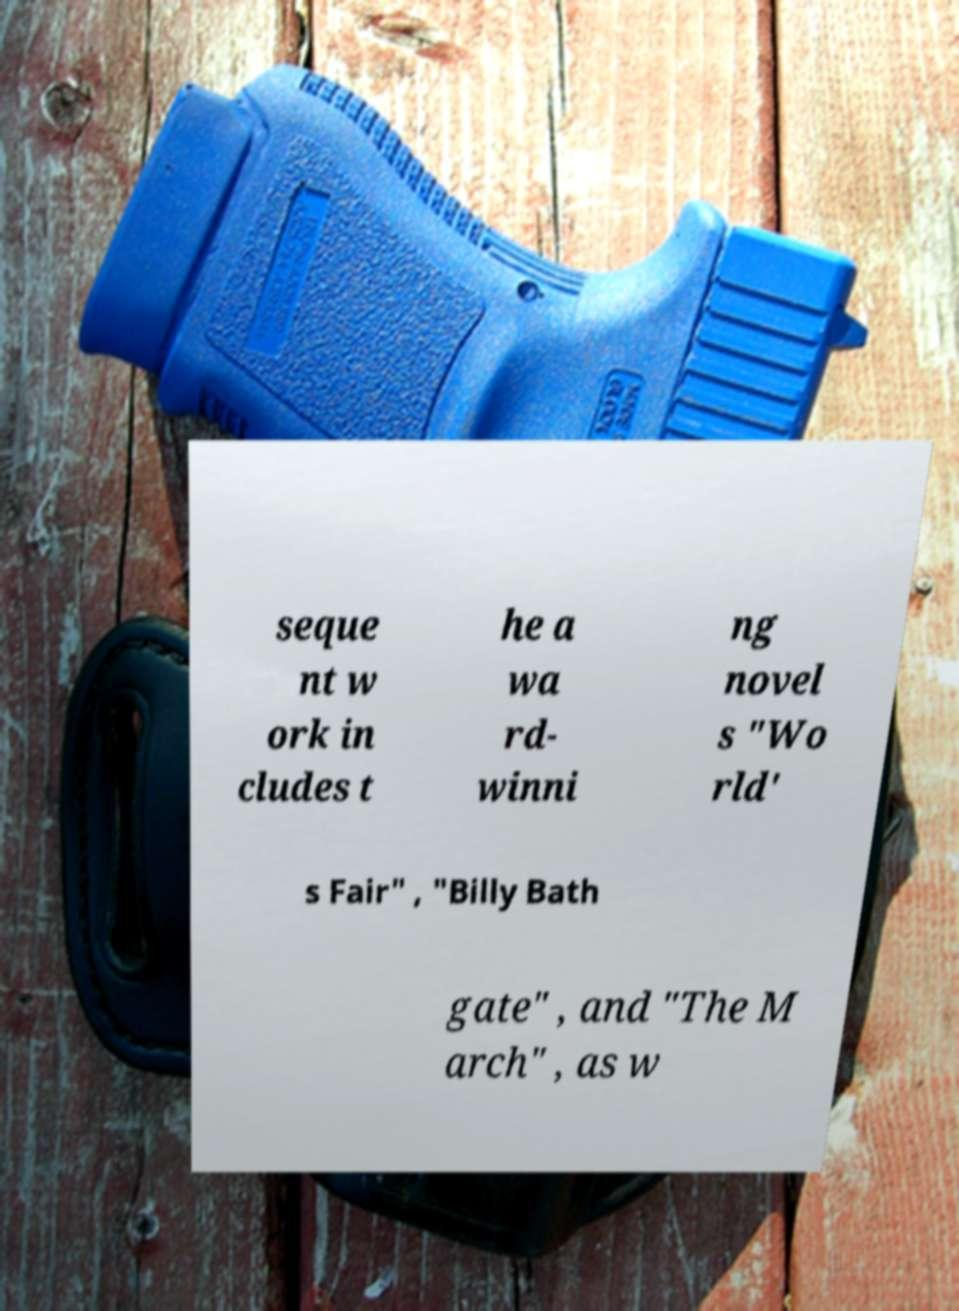What messages or text are displayed in this image? I need them in a readable, typed format. seque nt w ork in cludes t he a wa rd- winni ng novel s "Wo rld' s Fair" , "Billy Bath gate" , and "The M arch" , as w 